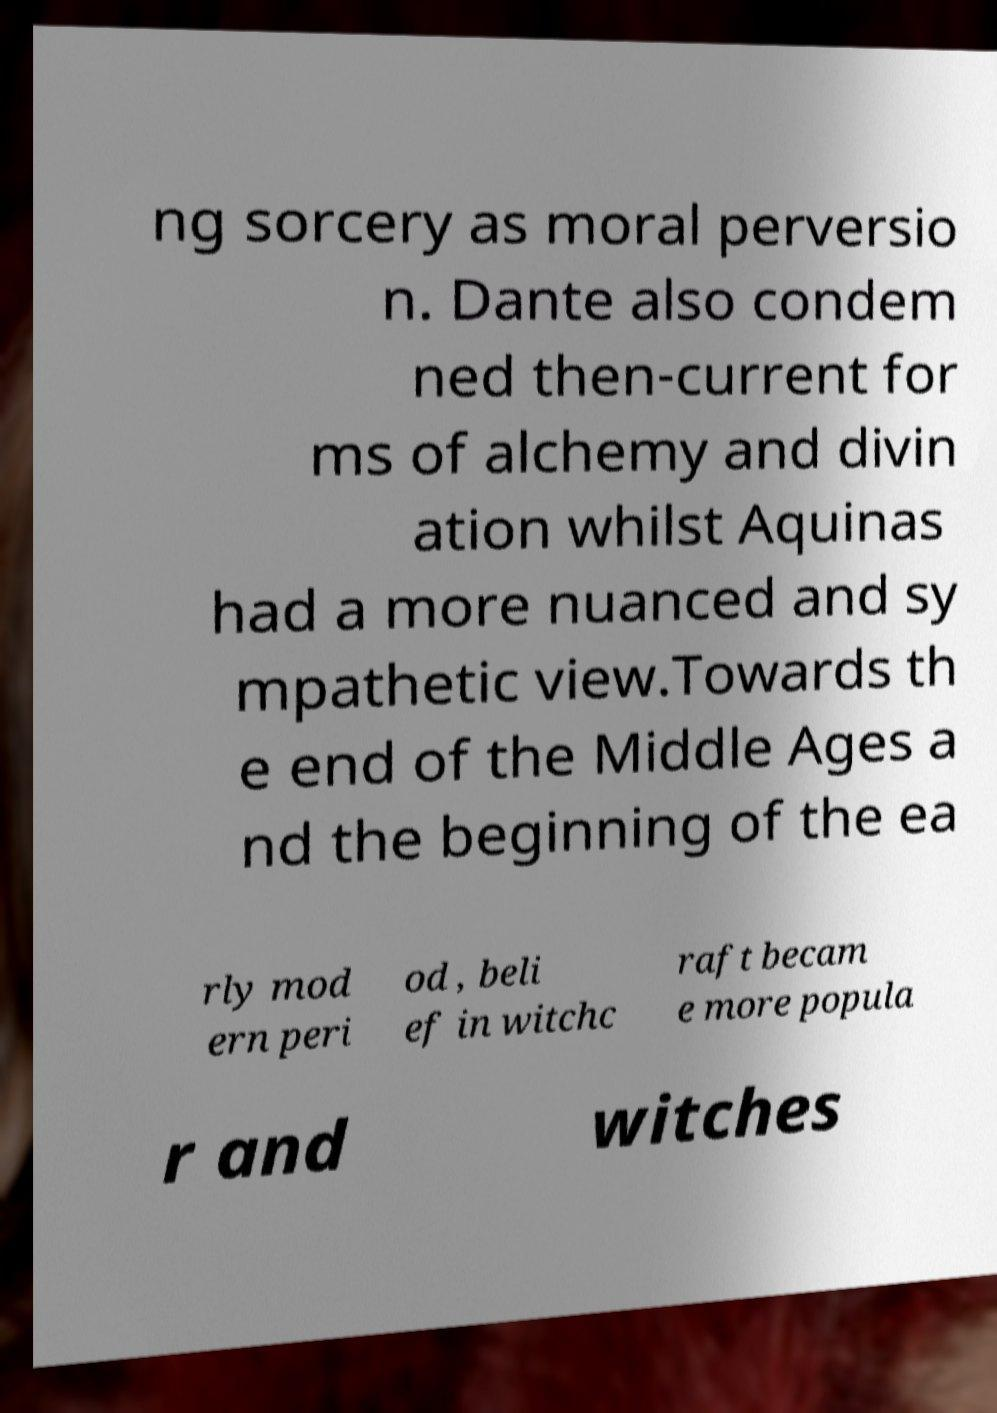I need the written content from this picture converted into text. Can you do that? ng sorcery as moral perversio n. Dante also condem ned then-current for ms of alchemy and divin ation whilst Aquinas had a more nuanced and sy mpathetic view.Towards th e end of the Middle Ages a nd the beginning of the ea rly mod ern peri od , beli ef in witchc raft becam e more popula r and witches 